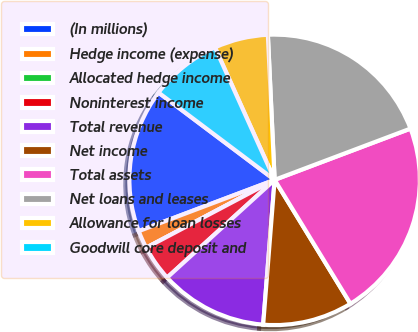<chart> <loc_0><loc_0><loc_500><loc_500><pie_chart><fcel>(In millions)<fcel>Hedge income (expense)<fcel>Allocated hedge income<fcel>Noninterest income<fcel>Total revenue<fcel>Net income<fcel>Total assets<fcel>Net loans and leases<fcel>Allowance for loan losses<fcel>Goodwill core deposit and<nl><fcel>16.0%<fcel>2.0%<fcel>0.0%<fcel>4.0%<fcel>12.0%<fcel>10.0%<fcel>22.0%<fcel>20.0%<fcel>6.0%<fcel>8.0%<nl></chart> 